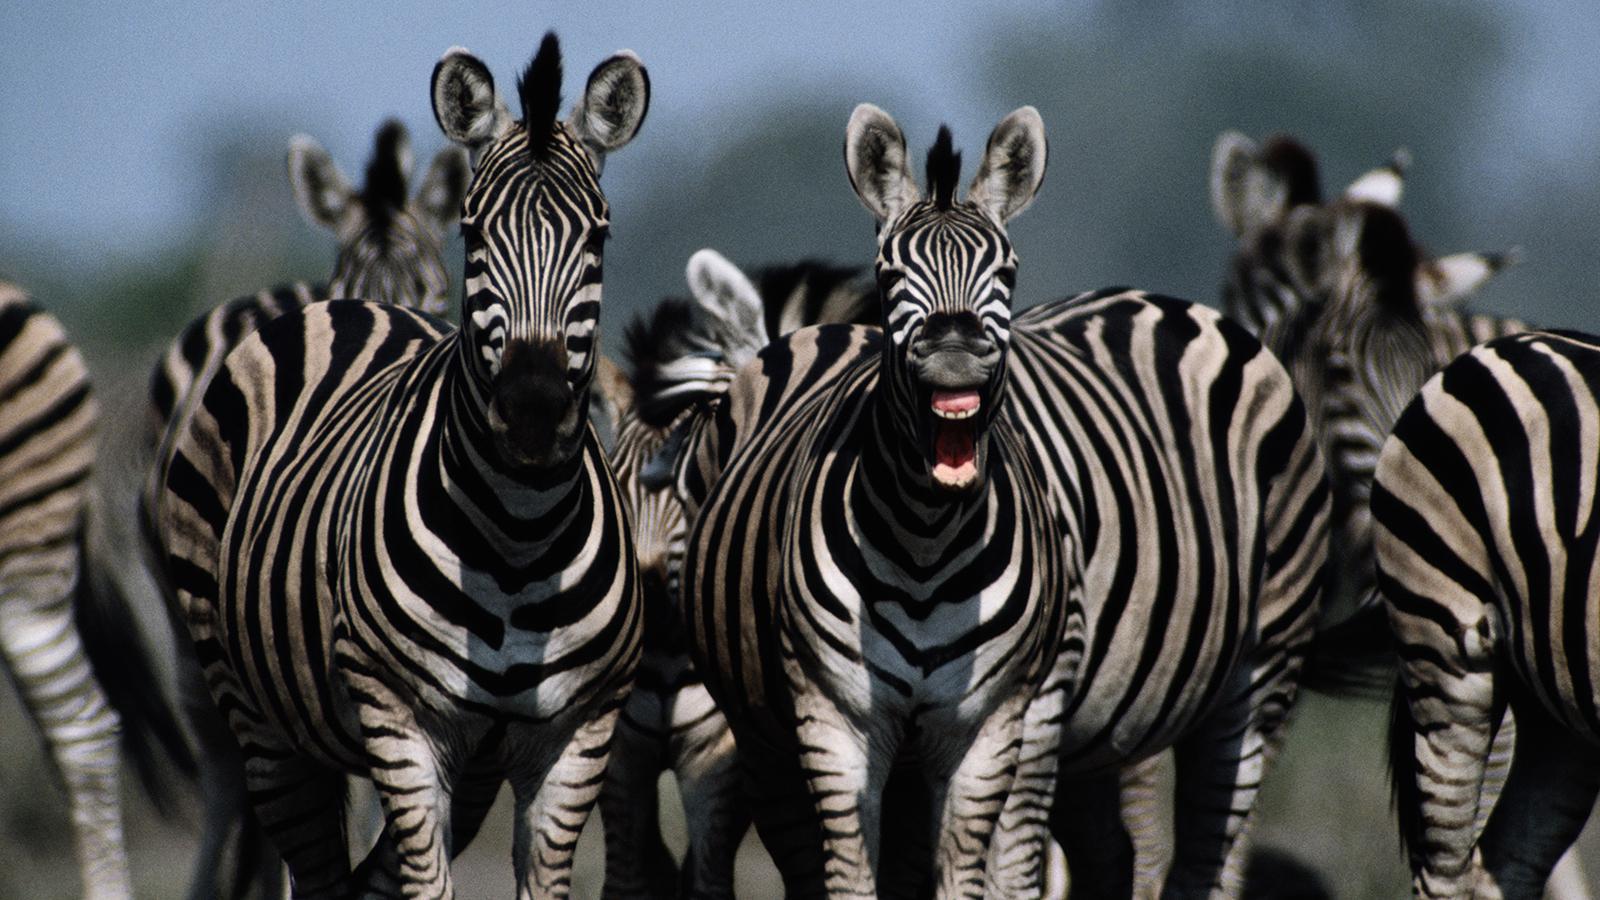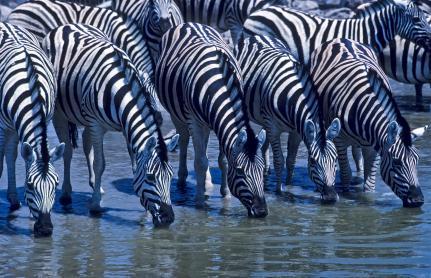The first image is the image on the left, the second image is the image on the right. Assess this claim about the two images: "In at least one image, zebras are drinking water.". Correct or not? Answer yes or no. Yes. The first image is the image on the left, the second image is the image on the right. Given the left and right images, does the statement "At least five zebras are drinking water." hold true? Answer yes or no. Yes. 